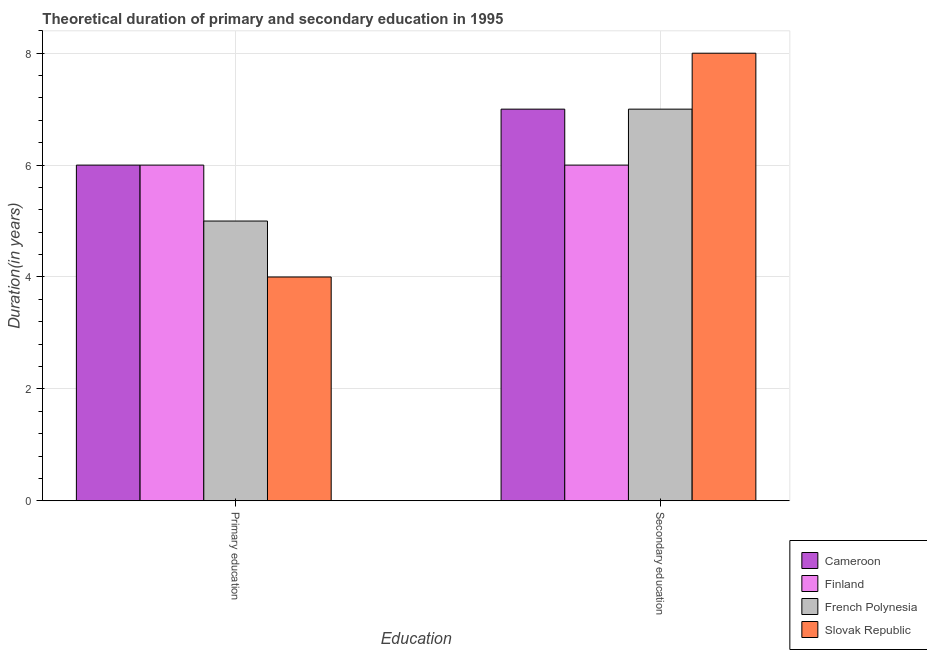How many groups of bars are there?
Provide a short and direct response. 2. Are the number of bars per tick equal to the number of legend labels?
Give a very brief answer. Yes. What is the label of the 2nd group of bars from the left?
Provide a short and direct response. Secondary education. What is the duration of primary education in Slovak Republic?
Offer a very short reply. 4. Across all countries, what is the maximum duration of secondary education?
Give a very brief answer. 8. Across all countries, what is the minimum duration of secondary education?
Provide a short and direct response. 6. In which country was the duration of primary education maximum?
Your answer should be very brief. Cameroon. In which country was the duration of primary education minimum?
Provide a short and direct response. Slovak Republic. What is the total duration of primary education in the graph?
Your response must be concise. 21. What is the difference between the duration of primary education in French Polynesia and that in Slovak Republic?
Offer a terse response. 1. What is the difference between the duration of secondary education in French Polynesia and the duration of primary education in Finland?
Provide a short and direct response. 1. What is the average duration of primary education per country?
Keep it short and to the point. 5.25. What is the difference between the duration of secondary education and duration of primary education in French Polynesia?
Offer a terse response. 2. In how many countries, is the duration of secondary education greater than 6.4 years?
Make the answer very short. 3. What is the ratio of the duration of secondary education in Slovak Republic to that in Cameroon?
Provide a succinct answer. 1.14. Is the duration of primary education in Finland less than that in Cameroon?
Keep it short and to the point. No. What does the 4th bar from the left in Primary education represents?
Offer a terse response. Slovak Republic. What is the difference between two consecutive major ticks on the Y-axis?
Make the answer very short. 2. Does the graph contain any zero values?
Keep it short and to the point. No. How are the legend labels stacked?
Your answer should be compact. Vertical. What is the title of the graph?
Keep it short and to the point. Theoretical duration of primary and secondary education in 1995. Does "Dominican Republic" appear as one of the legend labels in the graph?
Give a very brief answer. No. What is the label or title of the X-axis?
Provide a succinct answer. Education. What is the label or title of the Y-axis?
Give a very brief answer. Duration(in years). What is the Duration(in years) in Finland in Secondary education?
Ensure brevity in your answer.  6. What is the Duration(in years) of French Polynesia in Secondary education?
Provide a short and direct response. 7. What is the Duration(in years) of Slovak Republic in Secondary education?
Give a very brief answer. 8. Across all Education, what is the maximum Duration(in years) in Cameroon?
Provide a succinct answer. 7. Across all Education, what is the maximum Duration(in years) of Finland?
Give a very brief answer. 6. Across all Education, what is the maximum Duration(in years) of Slovak Republic?
Provide a short and direct response. 8. Across all Education, what is the minimum Duration(in years) of French Polynesia?
Keep it short and to the point. 5. What is the total Duration(in years) of Cameroon in the graph?
Offer a terse response. 13. What is the total Duration(in years) of French Polynesia in the graph?
Provide a succinct answer. 12. What is the total Duration(in years) of Slovak Republic in the graph?
Keep it short and to the point. 12. What is the difference between the Duration(in years) of Cameroon in Primary education and that in Secondary education?
Your answer should be compact. -1. What is the difference between the Duration(in years) in Finland in Primary education and that in Secondary education?
Your response must be concise. 0. What is the difference between the Duration(in years) in French Polynesia in Primary education and that in Secondary education?
Provide a short and direct response. -2. What is the difference between the Duration(in years) in Slovak Republic in Primary education and that in Secondary education?
Keep it short and to the point. -4. What is the difference between the Duration(in years) of Cameroon in Primary education and the Duration(in years) of French Polynesia in Secondary education?
Your answer should be very brief. -1. What is the difference between the Duration(in years) of Finland in Primary education and the Duration(in years) of French Polynesia in Secondary education?
Ensure brevity in your answer.  -1. What is the difference between the Duration(in years) in French Polynesia in Primary education and the Duration(in years) in Slovak Republic in Secondary education?
Make the answer very short. -3. What is the average Duration(in years) of Finland per Education?
Provide a succinct answer. 6. What is the difference between the Duration(in years) of Cameroon and Duration(in years) of Slovak Republic in Primary education?
Offer a terse response. 2. What is the difference between the Duration(in years) in Finland and Duration(in years) in Slovak Republic in Primary education?
Your response must be concise. 2. What is the difference between the Duration(in years) in French Polynesia and Duration(in years) in Slovak Republic in Primary education?
Offer a very short reply. 1. What is the difference between the Duration(in years) of Cameroon and Duration(in years) of Finland in Secondary education?
Your answer should be compact. 1. What is the difference between the Duration(in years) of Cameroon and Duration(in years) of French Polynesia in Secondary education?
Give a very brief answer. 0. What is the difference between the Duration(in years) in Cameroon and Duration(in years) in Slovak Republic in Secondary education?
Give a very brief answer. -1. What is the difference between the Duration(in years) in Finland and Duration(in years) in French Polynesia in Secondary education?
Your answer should be very brief. -1. What is the difference between the Duration(in years) of French Polynesia and Duration(in years) of Slovak Republic in Secondary education?
Your answer should be very brief. -1. What is the ratio of the Duration(in years) in Finland in Primary education to that in Secondary education?
Your response must be concise. 1. What is the ratio of the Duration(in years) of French Polynesia in Primary education to that in Secondary education?
Your response must be concise. 0.71. What is the ratio of the Duration(in years) of Slovak Republic in Primary education to that in Secondary education?
Make the answer very short. 0.5. What is the difference between the highest and the second highest Duration(in years) of Cameroon?
Your answer should be compact. 1. What is the difference between the highest and the lowest Duration(in years) in French Polynesia?
Offer a very short reply. 2. What is the difference between the highest and the lowest Duration(in years) in Slovak Republic?
Make the answer very short. 4. 